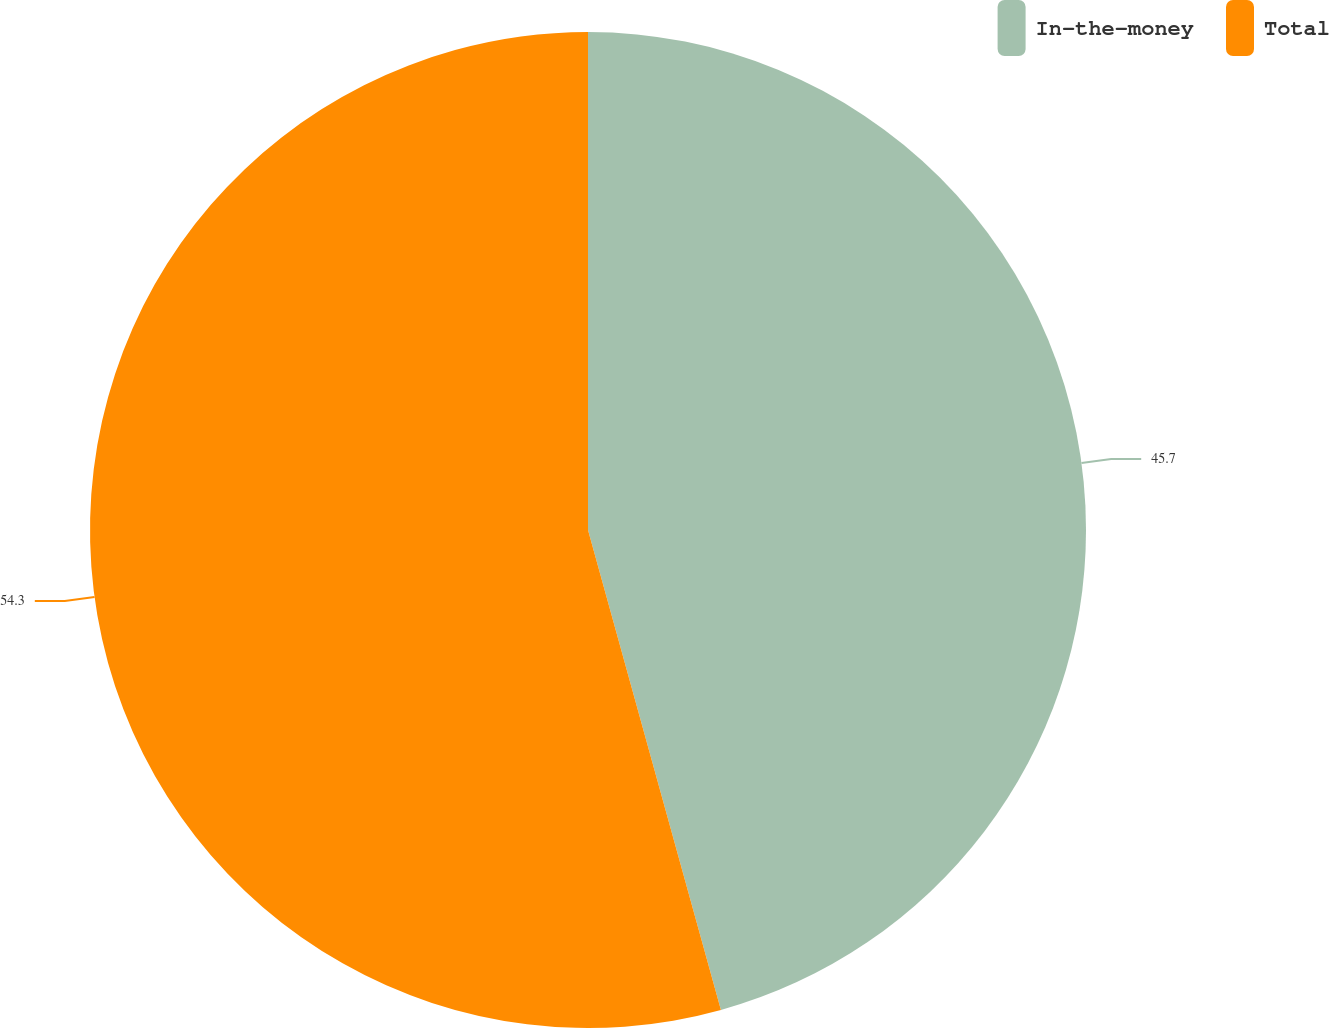Convert chart to OTSL. <chart><loc_0><loc_0><loc_500><loc_500><pie_chart><fcel>In-the-money<fcel>Total<nl><fcel>45.7%<fcel>54.3%<nl></chart> 